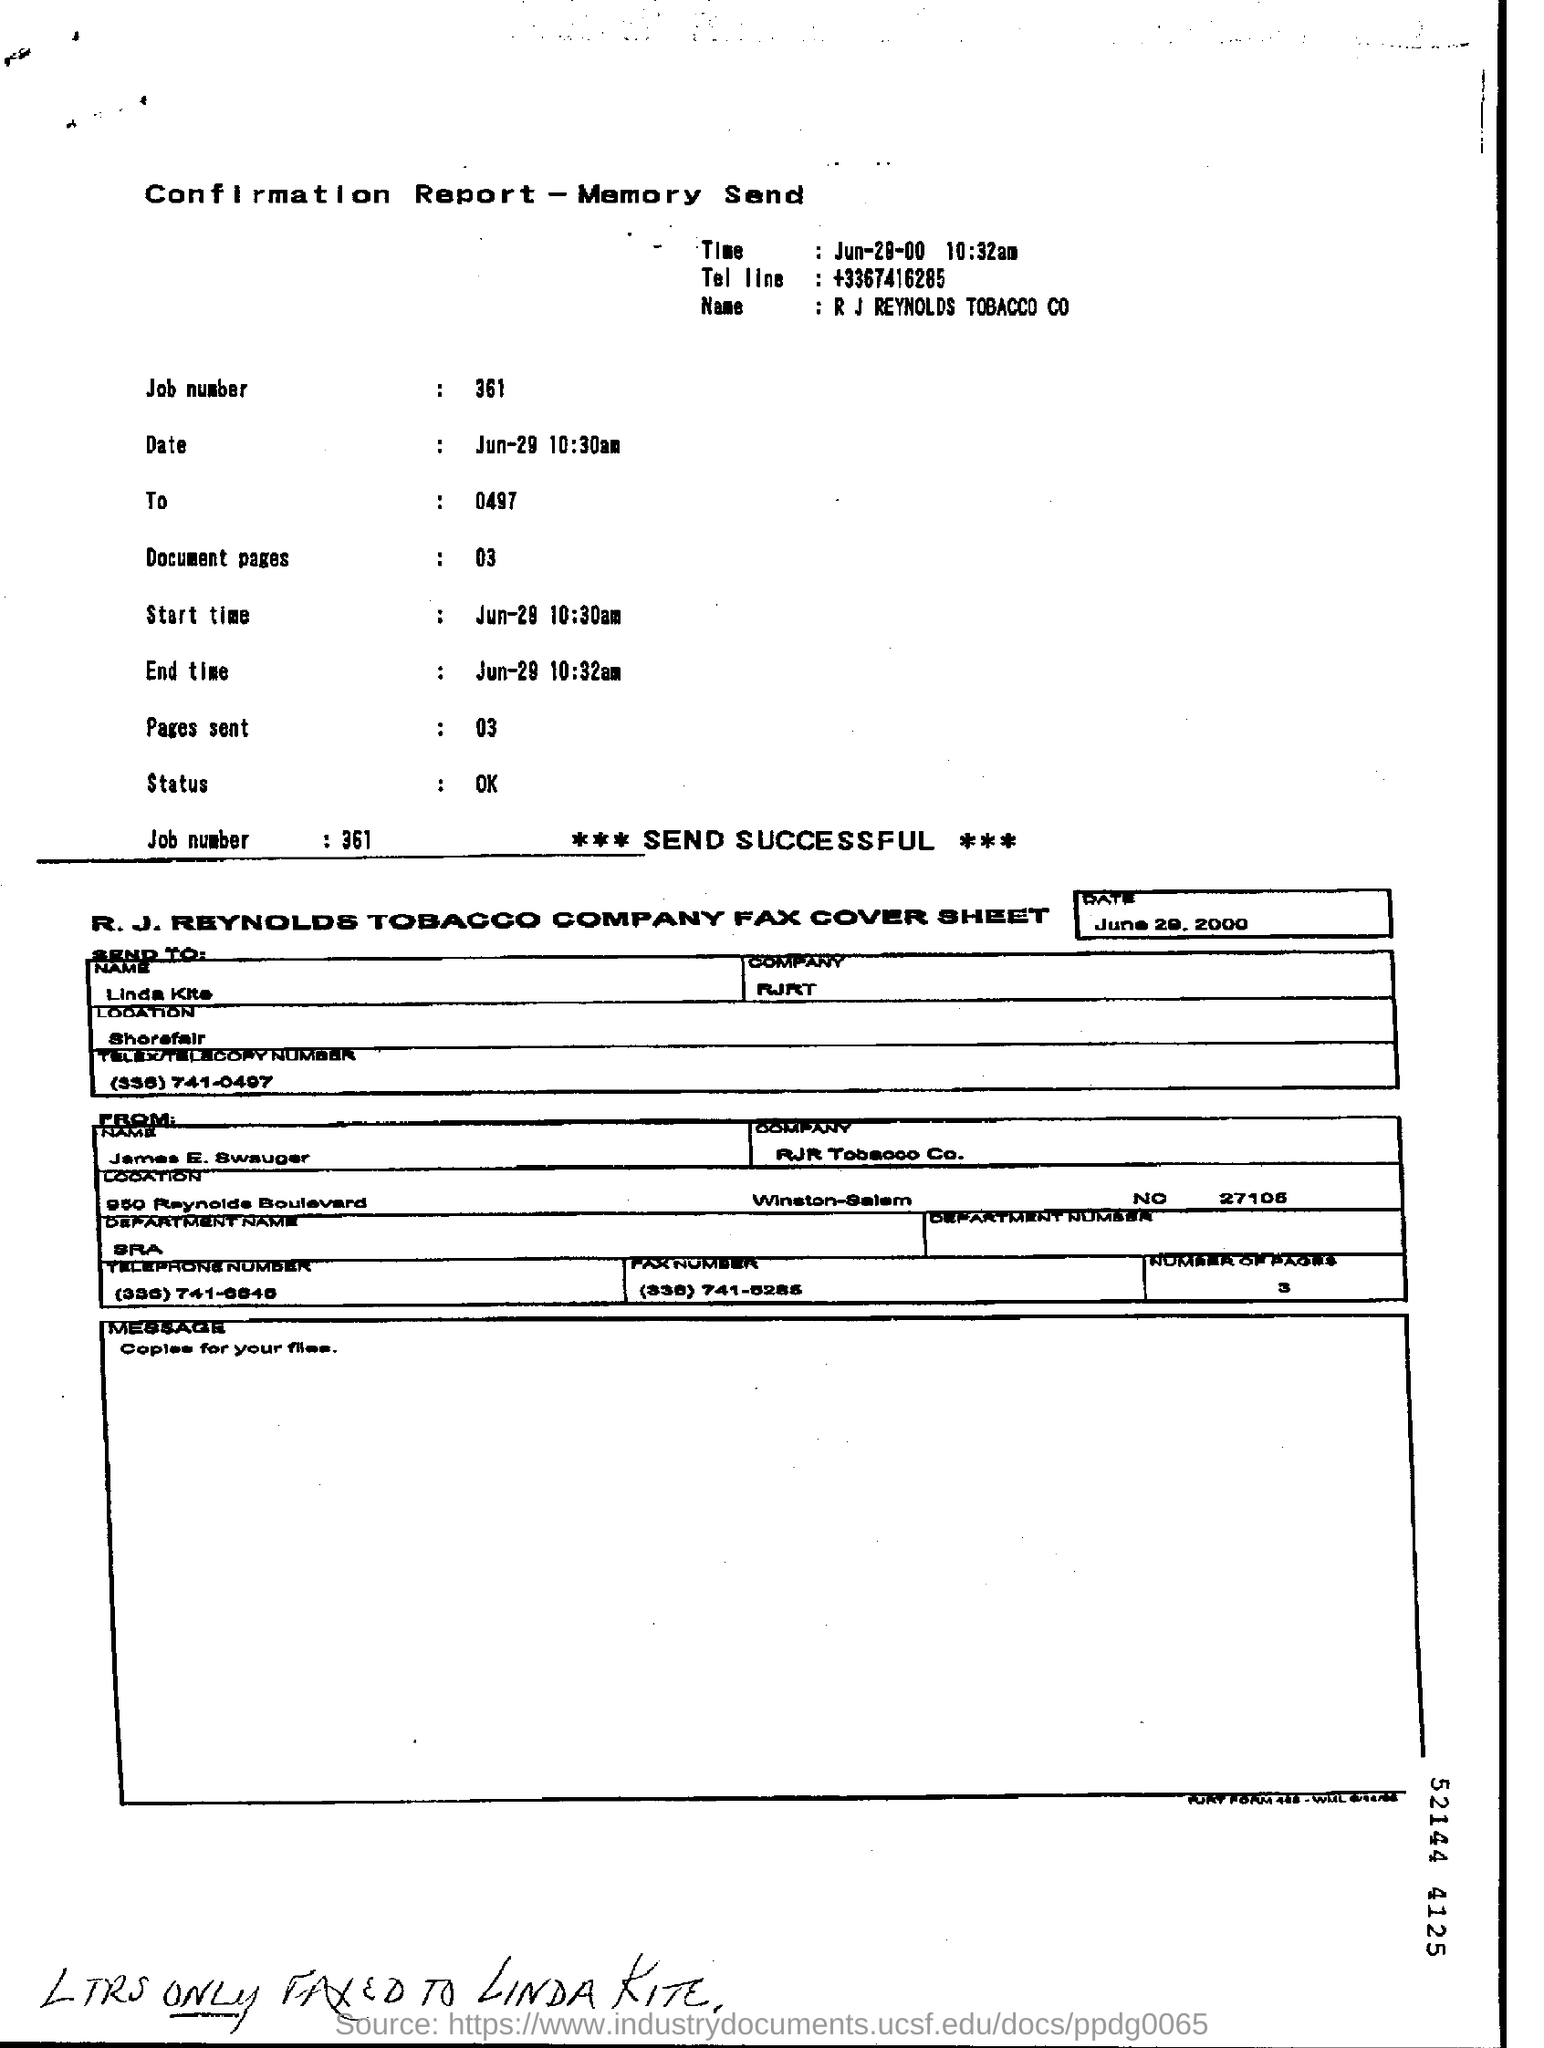Mention a couple of crucial points in this snapshot. The message on the fax is 'Copies for your files...' The number of document pages is 03. The fax is addressed to Linda Kite. The Tel line is a telephone number with the country code of France and the area code 67416285. The job number is 361... 